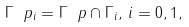<formula> <loc_0><loc_0><loc_500><loc_500>\Gamma \ p _ { i } = \Gamma \ p \cap \Gamma _ { i } , \, i = 0 , 1 ,</formula> 